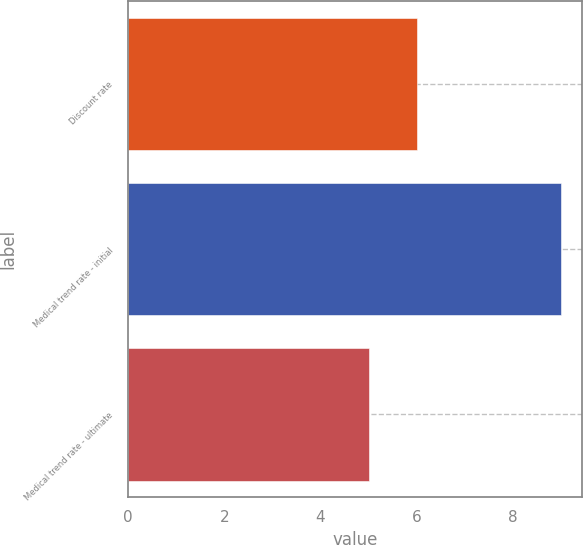Convert chart. <chart><loc_0><loc_0><loc_500><loc_500><bar_chart><fcel>Discount rate<fcel>Medical trend rate - initial<fcel>Medical trend rate - ultimate<nl><fcel>6<fcel>9<fcel>5<nl></chart> 